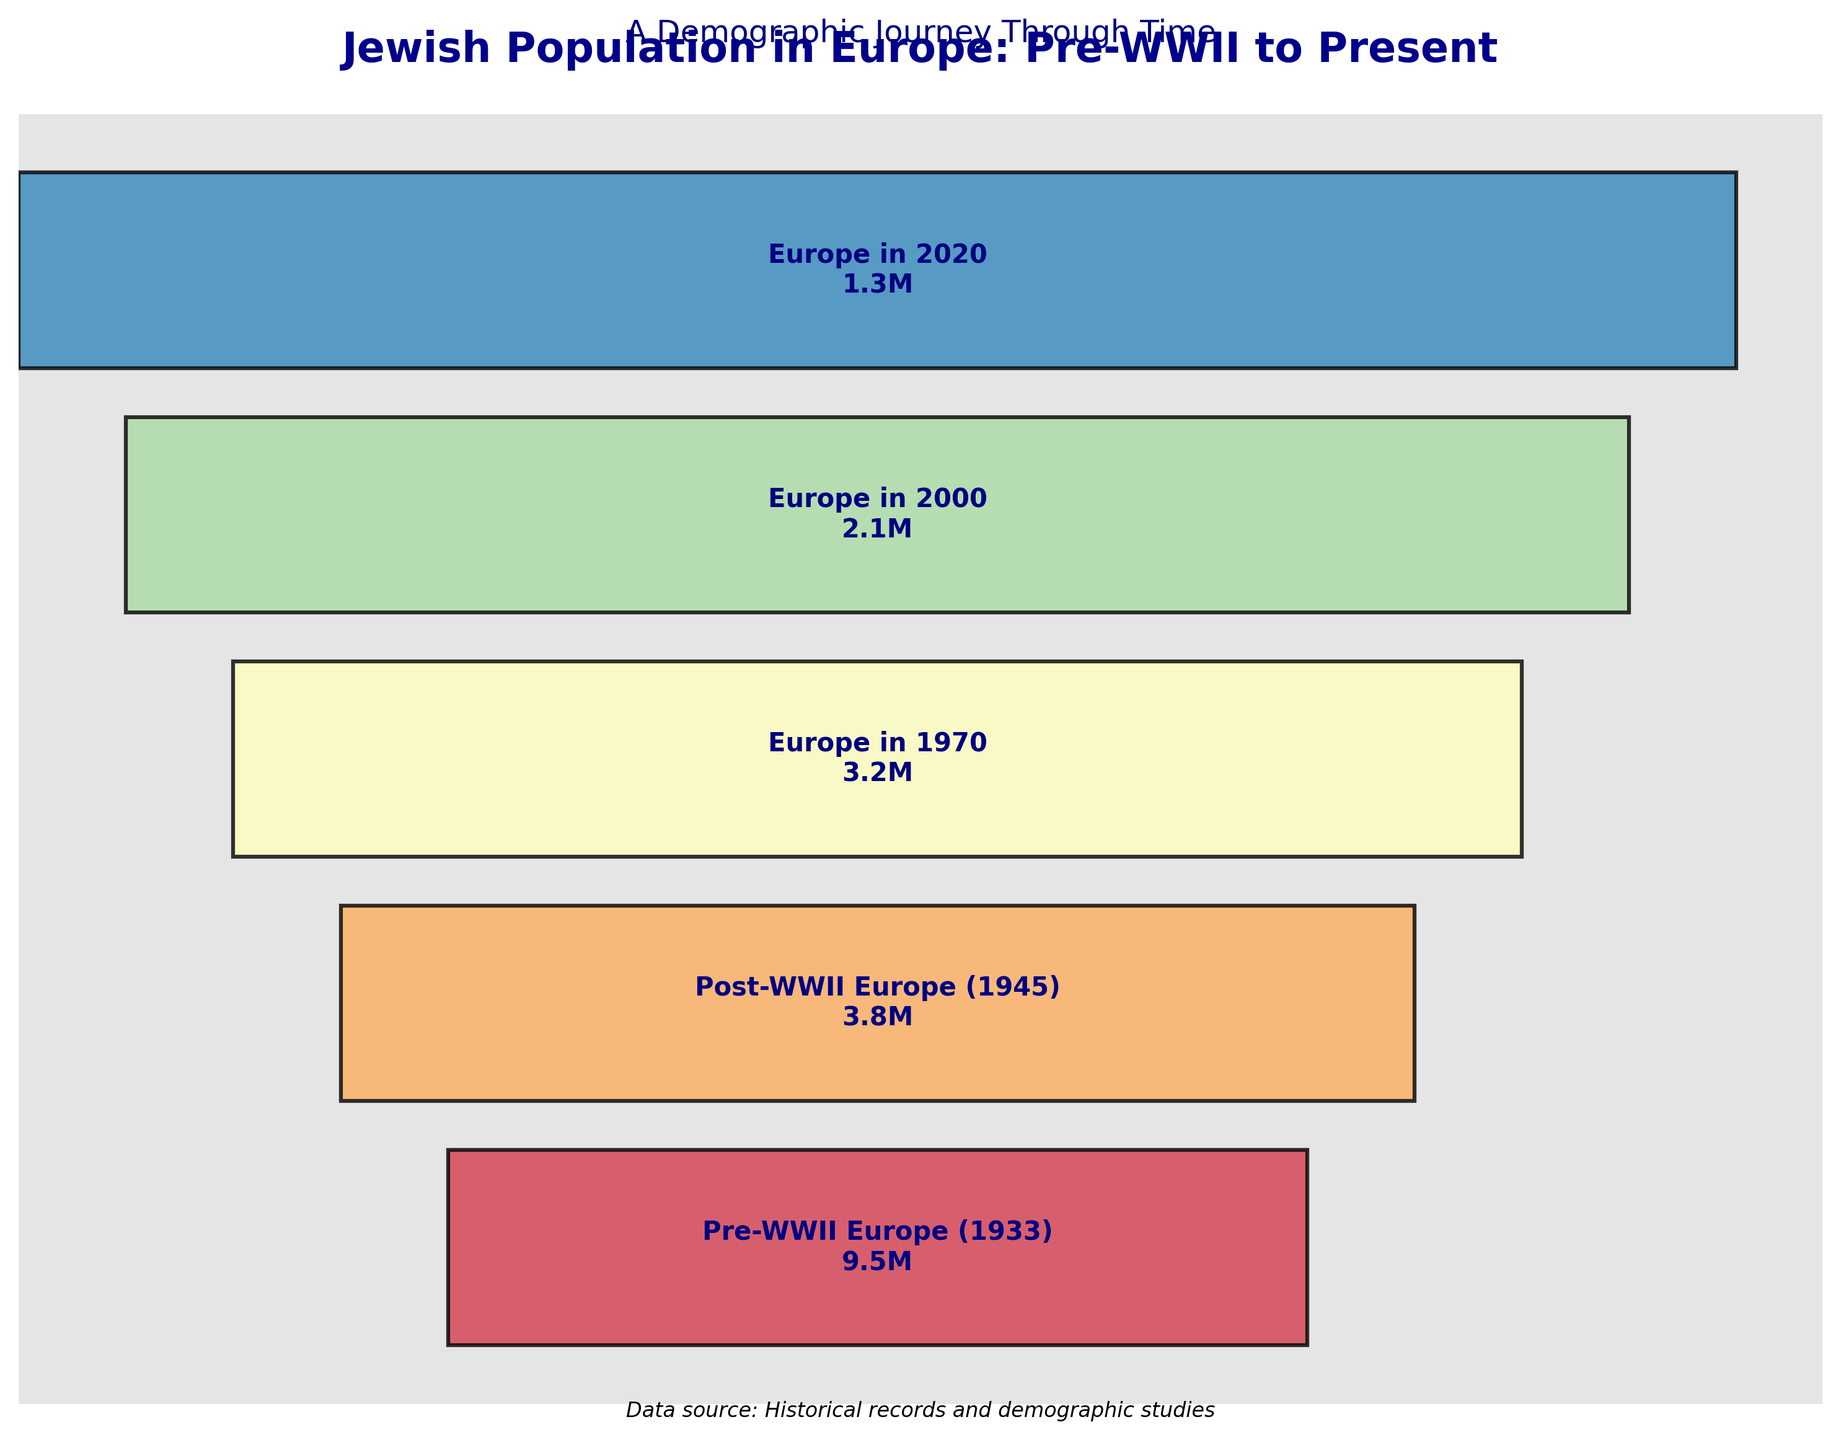What's the title of the plot? The title is usually displayed at the top of the chart in a larger, bold font and specifies the main subject of the visualization.
Answer: Jewish Population in Europe: Pre-WWII to Present How many stages are shown in the chart? By counting the number of differently colored segments, we can determine the total number of stages depicted.
Answer: 5 What was the Jewish population in Europe in the year 2000? The label within the funnel segment for the year 2000 states the population in millions.
Answer: 2.1 million Which period experienced the largest decline in Jewish population? By comparing the drops in population between adjacent stages on the funnel chart, we can see that the largest decline occurred between the Pre-WWII stage and the Post-WWII stage.
Answer: Between Pre-WWII (1933) and Post-WWII (1945) What is the difference in Jewish population between 1970 and 2000? Subtract the population in 2000 from the population in 1970 as displayed on the chart: 3.2M - 2.1M.
Answer: 1.1 million Which period shows the greatest percentage decrease in population? Calculate the percentage decrease for each period by dividing the difference in populations by the earlier period's population and multiplying by 100. The largest percentage decrease is between Pre-WWII and Post-WWII: ((9.5 - 3.8) / 9.5) * 100.
Answer: Between Pre-WWII (1933) and Post-WWII (1945) Which stage represents the lowest Jewish population? Identify the segment with the smallest population value displayed in the chart.
Answer: Europe in 2020 How does the population in 1945 compare to the population in 2020? Compare the two values directly. The population in 1945 is 3.8M, whereas in 2020 it is 1.3M, showing a greater population size in 1945.
Answer: The population in 1945 is greater than in 2020 What's the total decline in Jewish population from Pre-WWII to 2020? Subtract the population in 2020 from the population in Pre-WWII as displayed on the chart: 9.5M - 1.3M.
Answer: 8.2 million What general trend can be observed from the chart? The funnel segments generally decrease in size from the top (Pre-WWII) to the bottom (2020), indicating a consistent decline in the Jewish population in Europe across the periods.
Answer: Consistent decline in Jewish population 